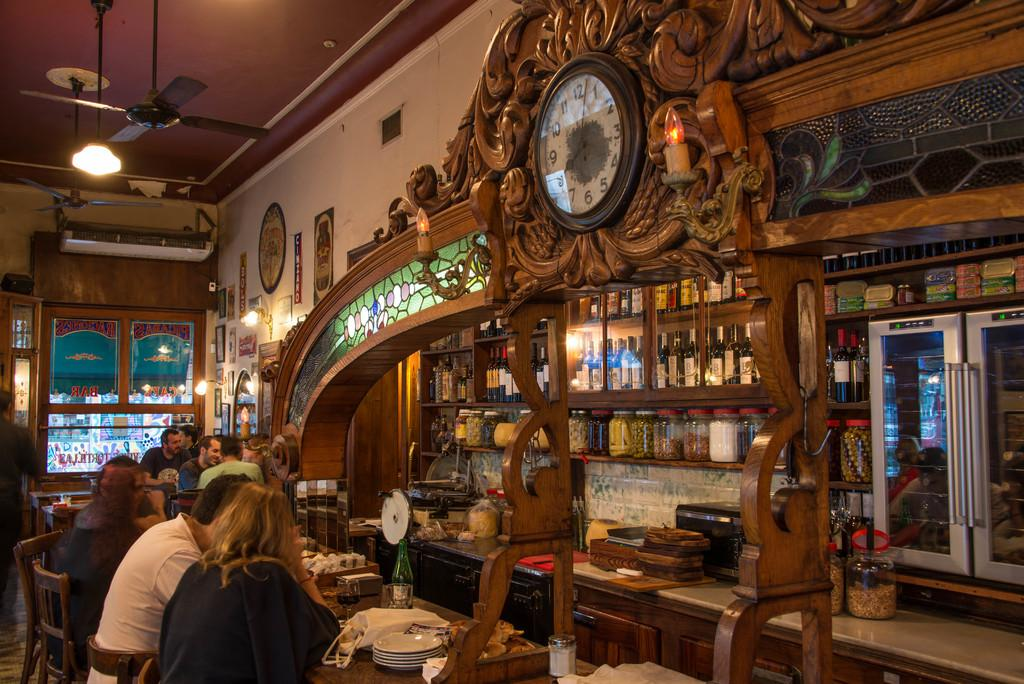What are the people in the image doing? The people in the image are seated. What are the people sitting on? The people are seated on chairs. What can be seen on the shelf in the image? There are bottles and jars on a shelf in the image. What can be seen on the countertop in the image? There are plates on a countertop in the image. How many trees can be seen in the image? There are no trees visible in the image. Is there a rifle present in the image? There is no rifle present in the image. 